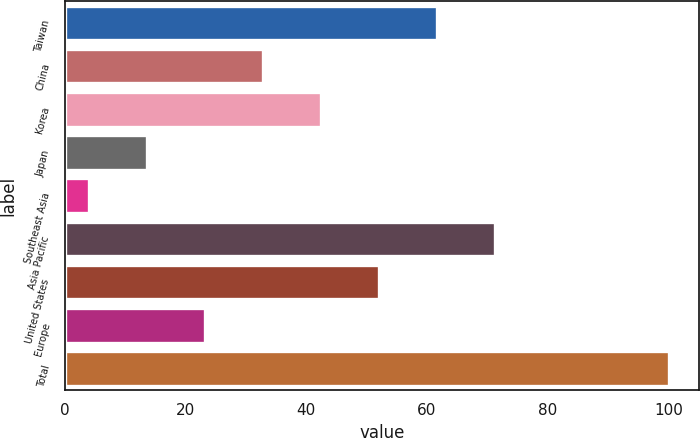<chart> <loc_0><loc_0><loc_500><loc_500><bar_chart><fcel>Taiwan<fcel>China<fcel>Korea<fcel>Japan<fcel>Southeast Asia<fcel>Asia Pacific<fcel>United States<fcel>Europe<fcel>Total<nl><fcel>61.6<fcel>32.8<fcel>42.4<fcel>13.6<fcel>4<fcel>71.2<fcel>52<fcel>23.2<fcel>100<nl></chart> 